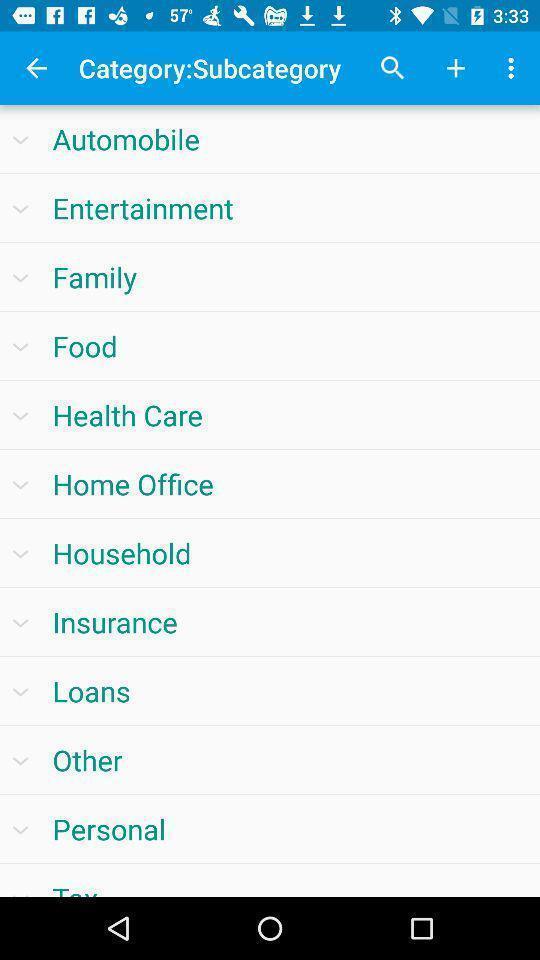Summarize the main components in this picture. Page showing list of categories. 